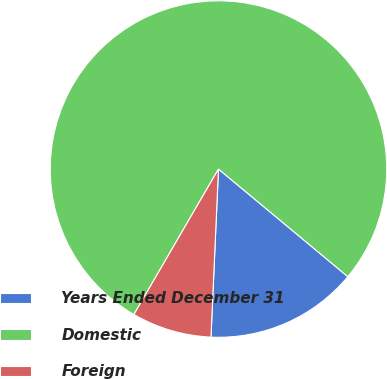<chart> <loc_0><loc_0><loc_500><loc_500><pie_chart><fcel>Years Ended December 31<fcel>Domestic<fcel>Foreign<nl><fcel>14.67%<fcel>77.66%<fcel>7.67%<nl></chart> 